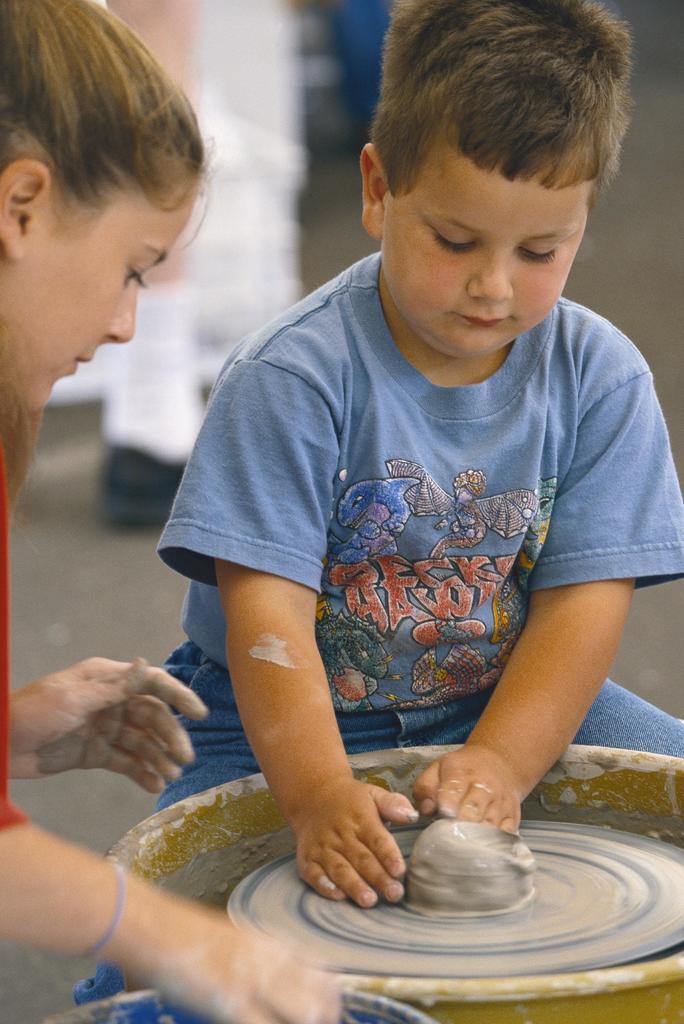How would you summarize this image in a sentence or two? In this image there are kids making a pot, in the background it is blurred. 